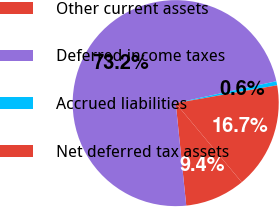Convert chart to OTSL. <chart><loc_0><loc_0><loc_500><loc_500><pie_chart><fcel>Other current assets<fcel>Deferred income taxes<fcel>Accrued liabilities<fcel>Net deferred tax assets<nl><fcel>9.44%<fcel>73.23%<fcel>0.64%<fcel>16.7%<nl></chart> 